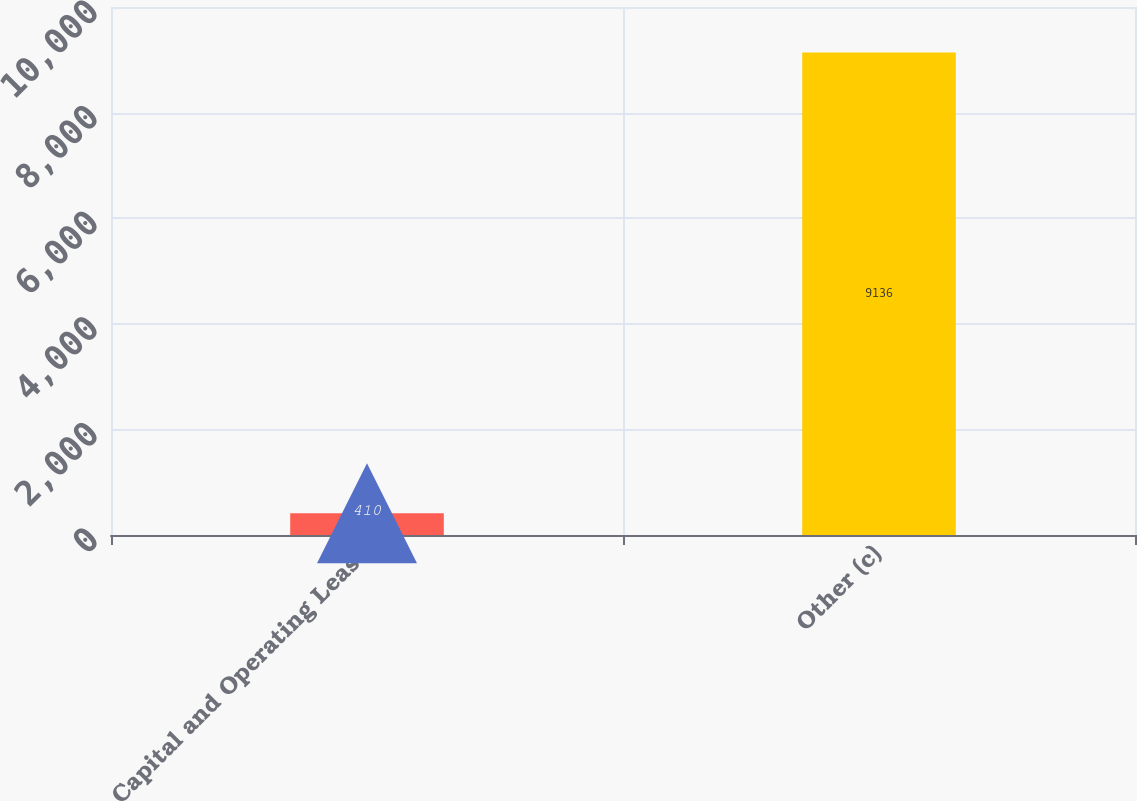Convert chart to OTSL. <chart><loc_0><loc_0><loc_500><loc_500><bar_chart><fcel>Capital and Operating Lease<fcel>Other (c)<nl><fcel>410<fcel>9136<nl></chart> 